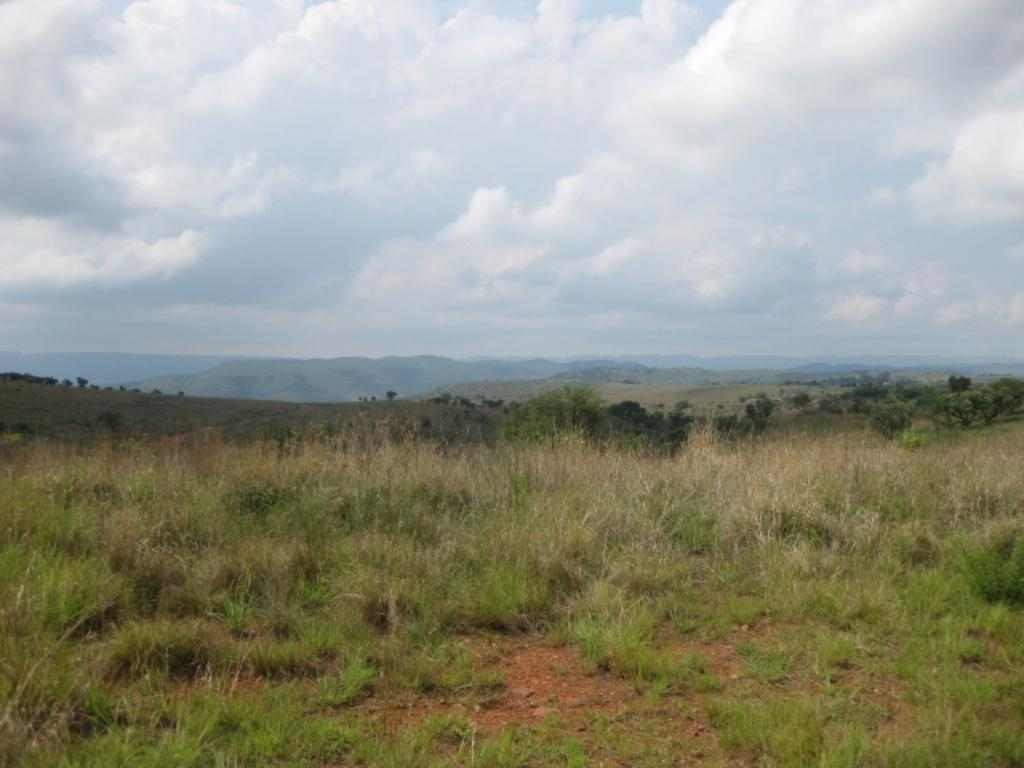What type of vegetation is present in the image? There are many trees and grass in the image. What can be seen in the background of the image? There are mountains in the background of the image. What is the condition of the sky in the image? The sky is cloudy at the top of the image. What type of horn can be seen on the trees in the image? There are no horns present on the trees in the image. What selection of bait is available for fishing in the image? There is no fishing or bait present in the image; it features trees, grass, mountains, and a cloudy sky. 